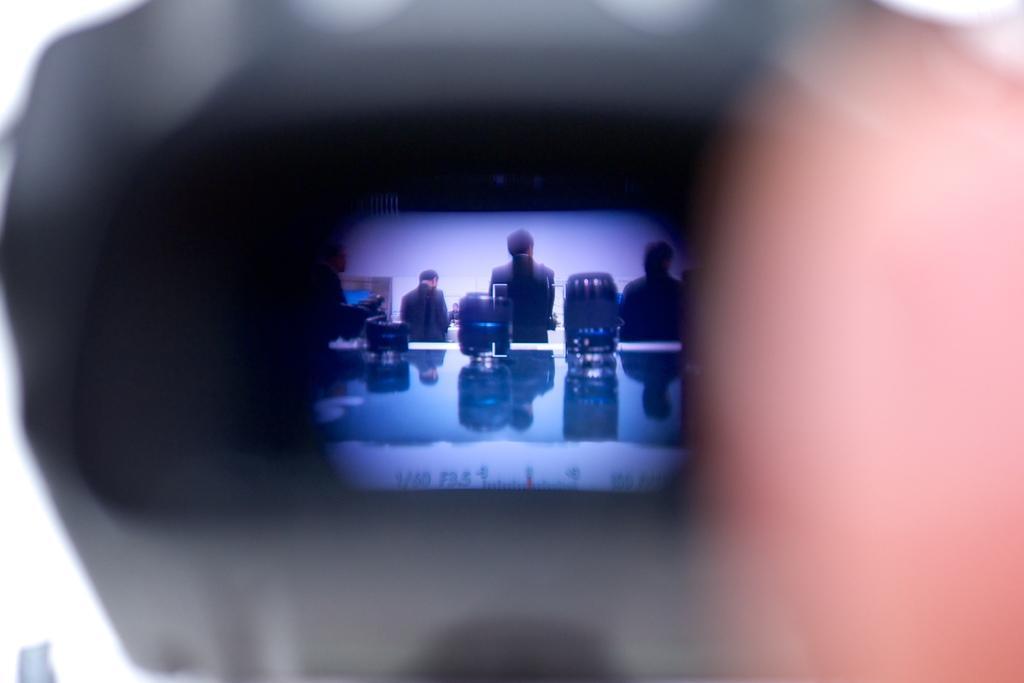Describe this image in one or two sentences. This is a blur image. It seems like a person's hand holding a camera. In the middle of the image there is a screen. On the screen, I can see few people facing towards the back side and there are few objects placed on a glass. 